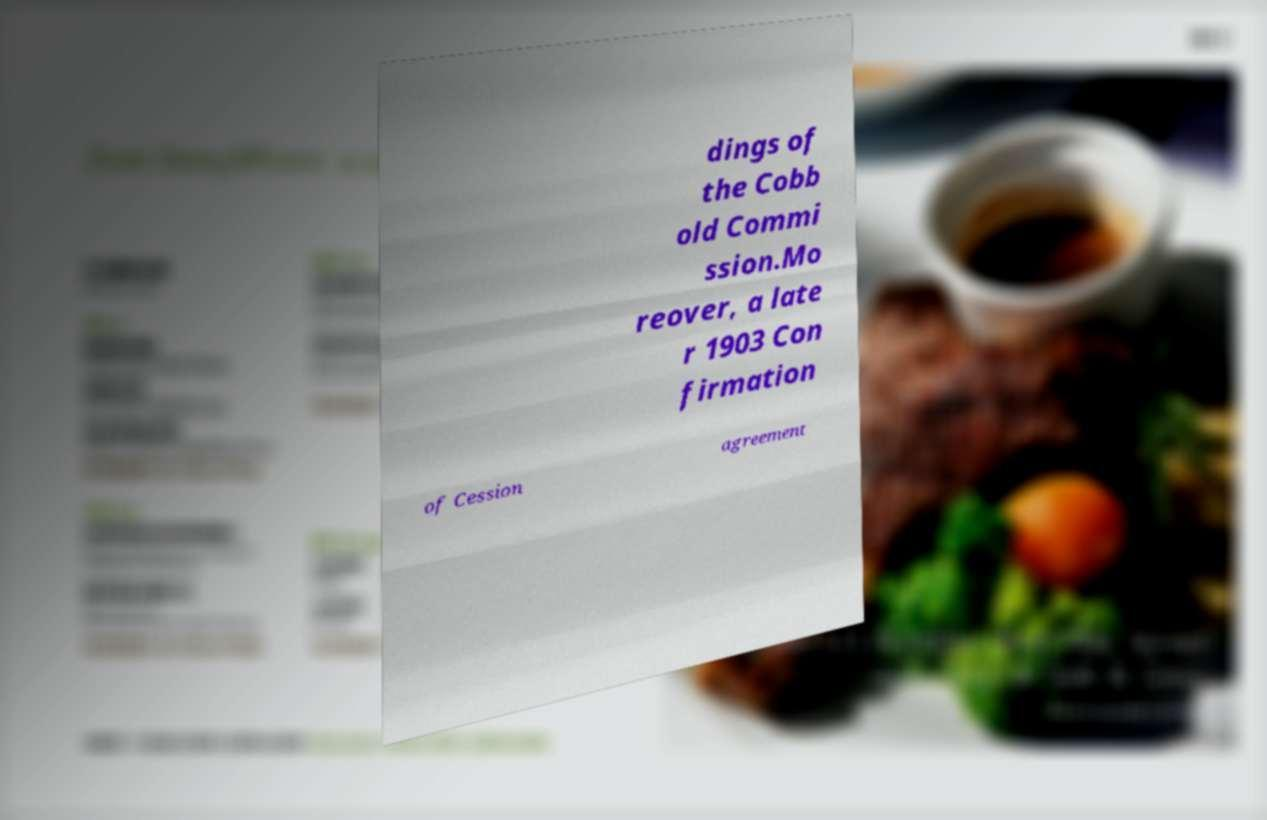There's text embedded in this image that I need extracted. Can you transcribe it verbatim? dings of the Cobb old Commi ssion.Mo reover, a late r 1903 Con firmation of Cession agreement 